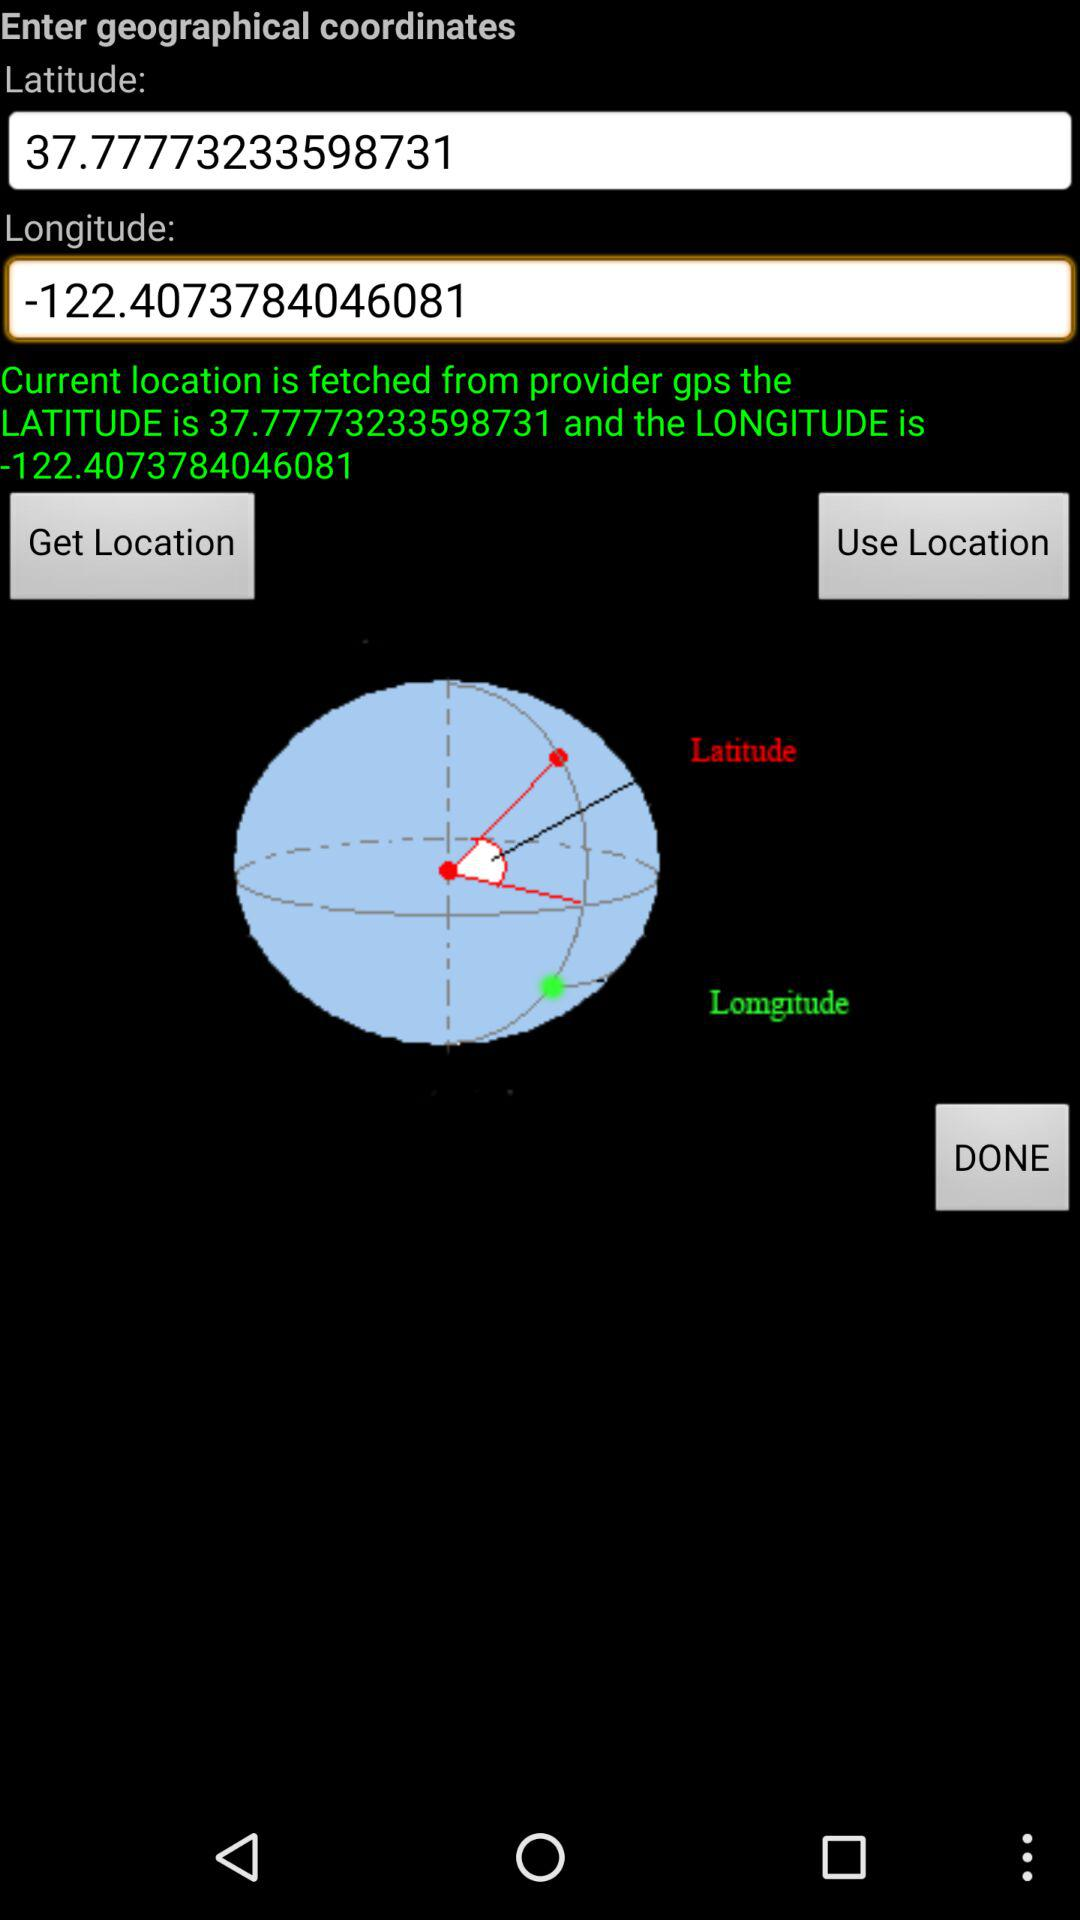How many text inputs are there for latitude and longitude?
Answer the question using a single word or phrase. 2 